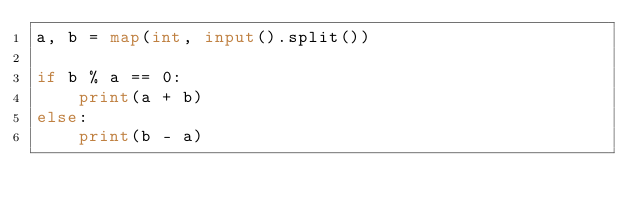Convert code to text. <code><loc_0><loc_0><loc_500><loc_500><_Python_>a, b = map(int, input().split())

if b % a == 0:
    print(a + b)
else:
    print(b - a)
</code> 